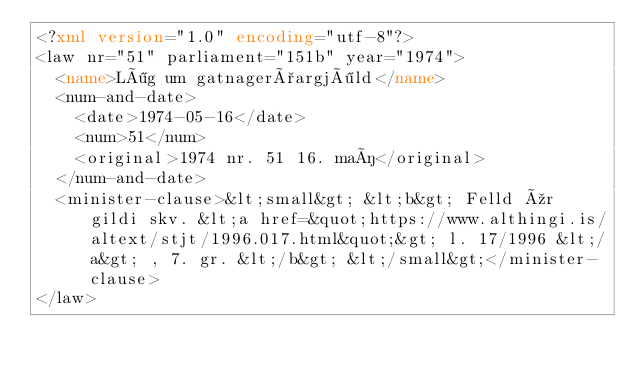<code> <loc_0><loc_0><loc_500><loc_500><_XML_><?xml version="1.0" encoding="utf-8"?>
<law nr="51" parliament="151b" year="1974">
  <name>Lög um gatnagerðargjöld</name>
  <num-and-date>
    <date>1974-05-16</date>
    <num>51</num>
    <original>1974 nr. 51 16. maí</original>
  </num-and-date>
  <minister-clause>&lt;small&gt; &lt;b&gt; Felld úr gildi skv. &lt;a href=&quot;https://www.althingi.is/altext/stjt/1996.017.html&quot;&gt; l. 17/1996 &lt;/a&gt; , 7. gr. &lt;/b&gt; &lt;/small&gt;</minister-clause>
</law>
</code> 